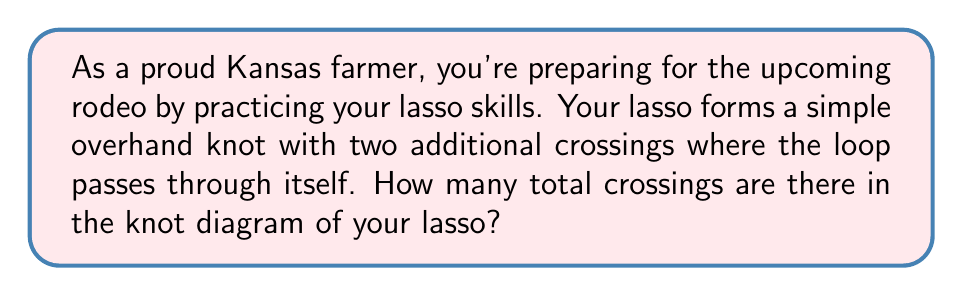Give your solution to this math problem. Let's break this down step-by-step:

1. First, recall that a simple overhand knot has 3 crossings.

2. The question states that there are two additional crossings where the loop passes through itself.

3. To calculate the total number of crossings, we need to add these together:

   $$ \text{Total crossings} = \text{Overhand knot crossings} + \text{Additional crossings} $$
   $$ \text{Total crossings} = 3 + 2 = 5 $$

4. Therefore, the knot diagram of the lasso has 5 crossings in total.

[asy]
import geometry;

size(200);

path p = (0,0)..(1,1)..(2,0)..(1,-1)..cycle;
path q = (0.5,-0.5)..(1.5,0.5);

draw(p, red);
draw(q, blue);

dot((0.75,0.25));
dot((1.25,-0.25));
dot((1,0.5));
dot((1,-0.5));
dot((1.5,0));
[/asy]

The diagram above illustrates a possible configuration of the lasso knot, where the red loop represents the overhand knot and the blue line represents the additional crossings of the lasso.
Answer: 5 crossings 